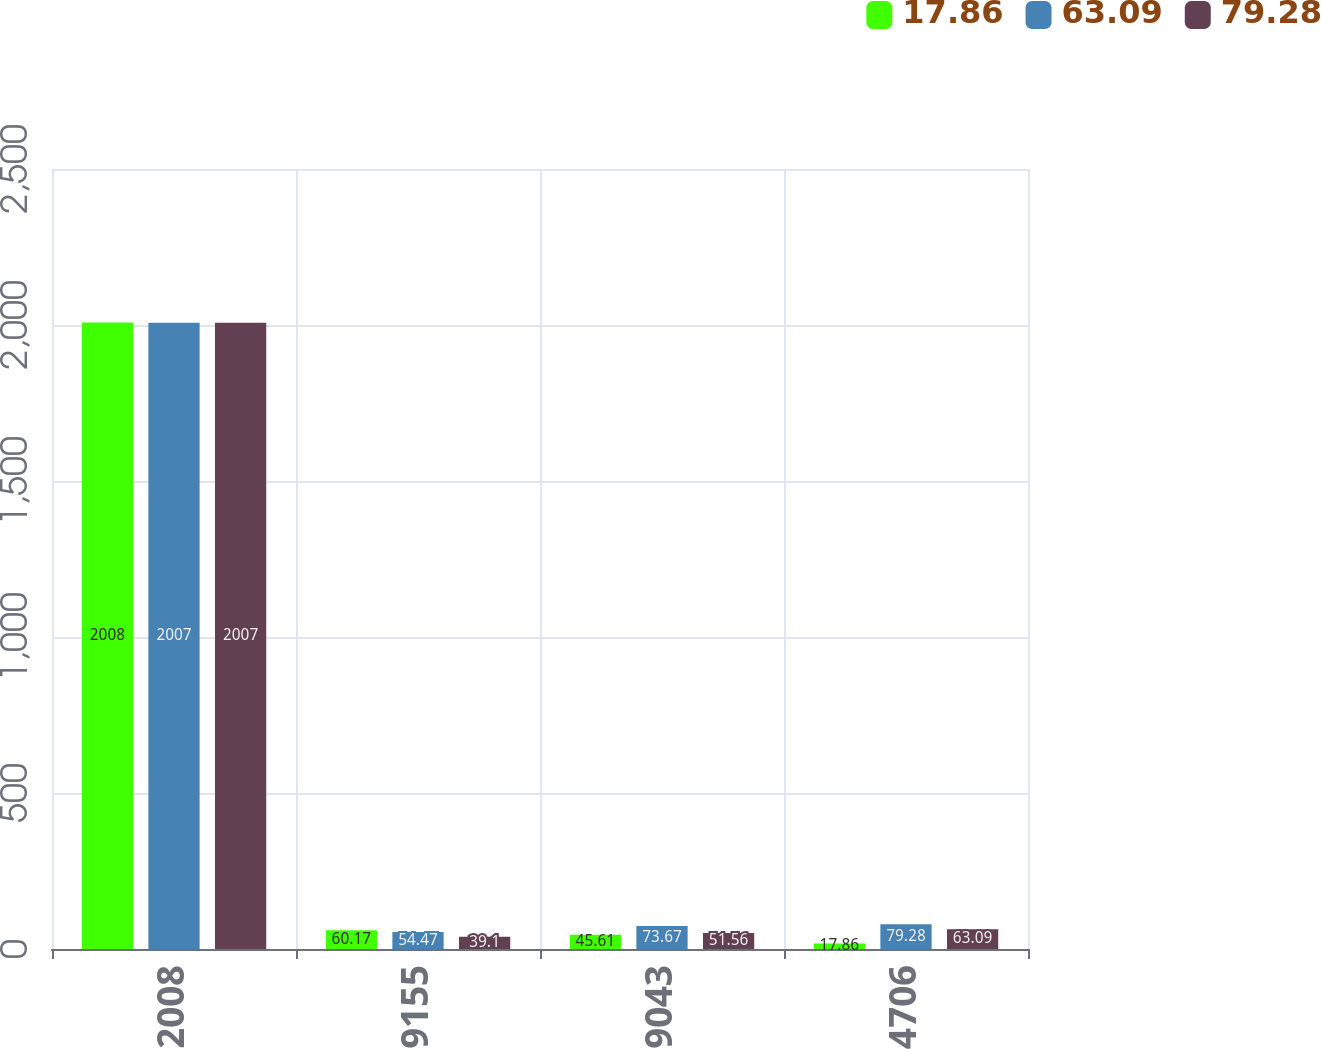<chart> <loc_0><loc_0><loc_500><loc_500><stacked_bar_chart><ecel><fcel>2008<fcel>9155<fcel>9043<fcel>4706<nl><fcel>17.86<fcel>2008<fcel>60.17<fcel>45.61<fcel>17.86<nl><fcel>63.09<fcel>2007<fcel>54.47<fcel>73.67<fcel>79.28<nl><fcel>79.28<fcel>2007<fcel>39.1<fcel>51.56<fcel>63.09<nl></chart> 